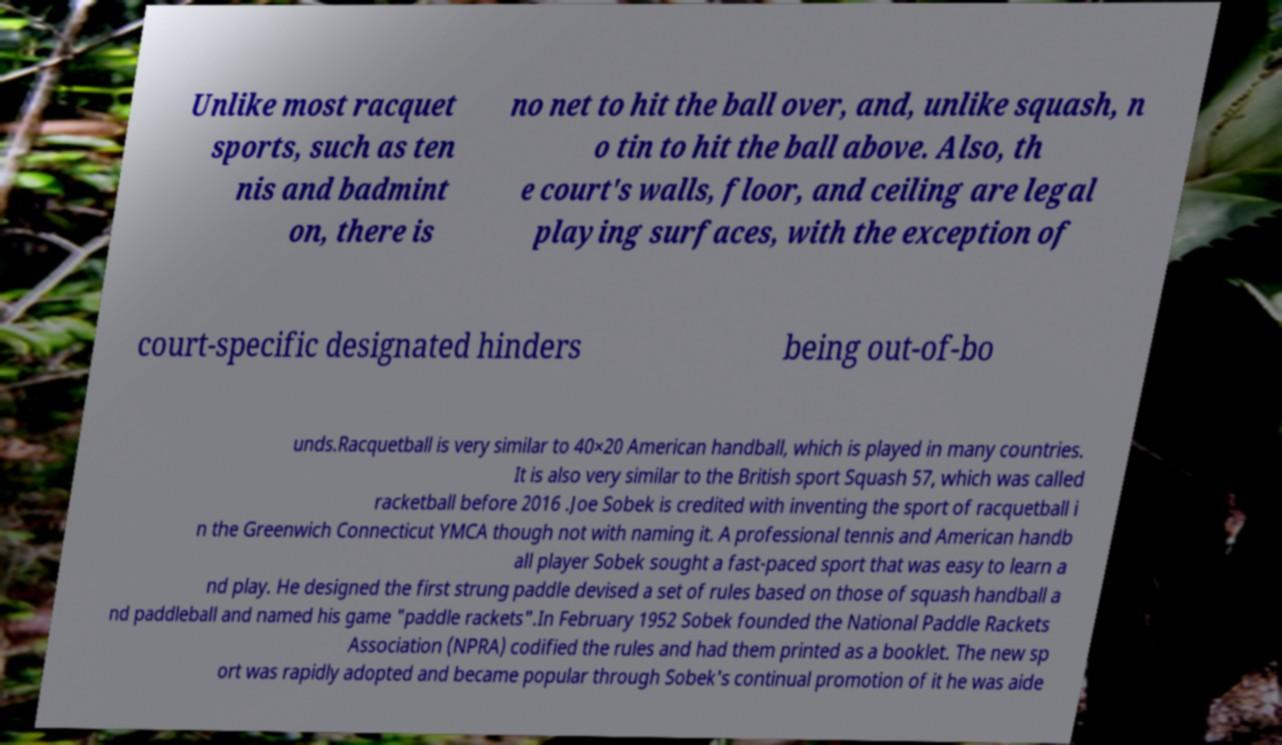For documentation purposes, I need the text within this image transcribed. Could you provide that? Unlike most racquet sports, such as ten nis and badmint on, there is no net to hit the ball over, and, unlike squash, n o tin to hit the ball above. Also, th e court's walls, floor, and ceiling are legal playing surfaces, with the exception of court-specific designated hinders being out-of-bo unds.Racquetball is very similar to 40×20 American handball, which is played in many countries. It is also very similar to the British sport Squash 57, which was called racketball before 2016 .Joe Sobek is credited with inventing the sport of racquetball i n the Greenwich Connecticut YMCA though not with naming it. A professional tennis and American handb all player Sobek sought a fast-paced sport that was easy to learn a nd play. He designed the first strung paddle devised a set of rules based on those of squash handball a nd paddleball and named his game "paddle rackets".In February 1952 Sobek founded the National Paddle Rackets Association (NPRA) codified the rules and had them printed as a booklet. The new sp ort was rapidly adopted and became popular through Sobek's continual promotion of it he was aide 